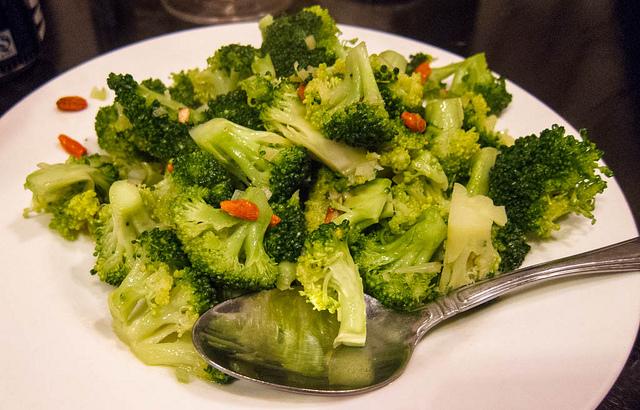What is the green food?
Concise answer only. Broccoli. Is more than one food group present?
Be succinct. No. What is in the broccoli?
Keep it brief. Carrots. Does the plate have a design?
Write a very short answer. No. What food is pictured here?
Keep it brief. Broccoli. What color is the dish that the broccoli is being served on?
Concise answer only. White. What is the topping on the dish?
Write a very short answer. Carrots. 